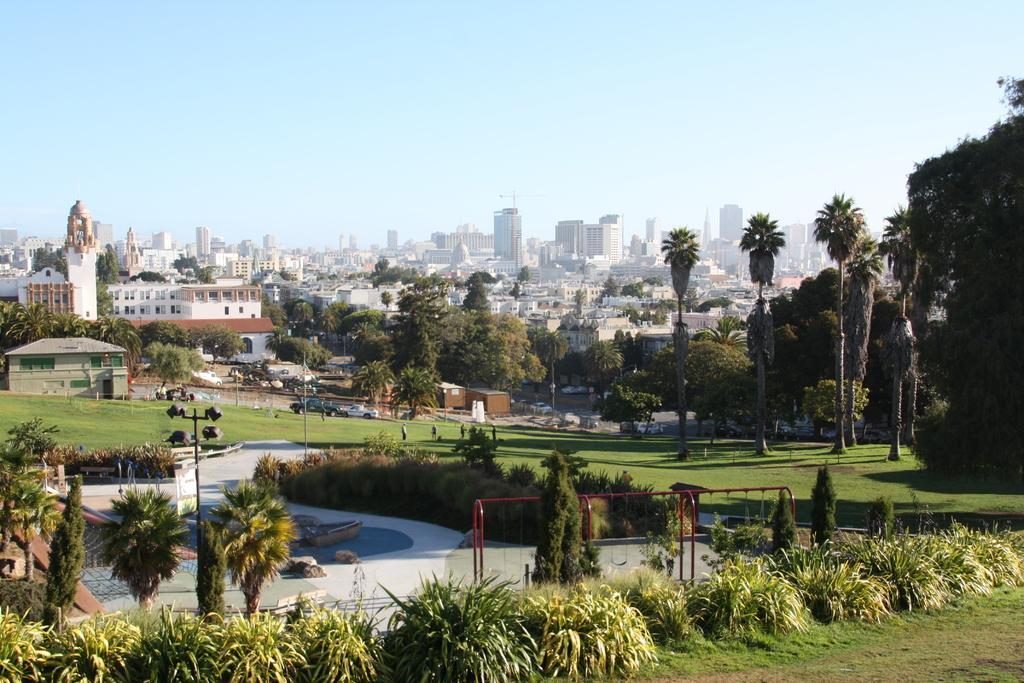How would you summarize this image in a sentence or two? In this picture we can see few plants, metal rods, poles, vehicles and few people on the grass, in the background we can see few trees and buildings. 